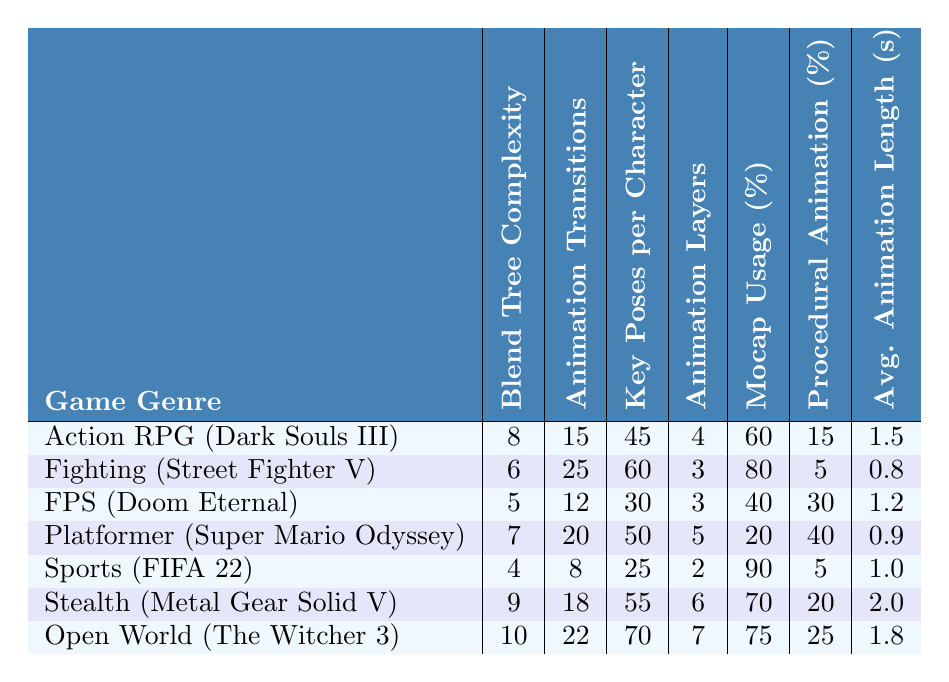What is the blend tree complexity for the Fighting genre? According to the table, the Fighting genre has a blend tree complexity of 6.
Answer: 6 Which game has the highest number of key poses per character? The Open World genre (The Witcher 3) has the highest number of key poses per character at 70.
Answer: 70 How many animation transitions does the Action RPG genre have? The Action RPG genre (Dark Souls III) has 15 animation transitions.
Answer: 15 Which genre has the lowest average animation length? The Fighting genre (Street Fighter V) has the lowest average animation length of 0.8 seconds.
Answer: 0.8 seconds What is the difference in blend tree complexity between the Open World and Sports genres? The Open World genre has a complexity of 10, while the Sports genre has a complexity of 4. The difference is 10 - 4 = 6.
Answer: 6 True or False: The FPS genre uses more motion capture percentage than the Action RPG genre. The FPS genre (Doom Eternal) uses 40% motion capture while the Action RPG genre (Dark Souls III) uses 60%. Thus, the statement is false.
Answer: False What is the average number of animation layers across all genres? The total animation layers are 4 + 3 + 3 + 5 + 2 + 6 + 7 = 30 and there are 7 genres. The average is 30 / 7 ≈ 4.29.
Answer: Approximately 4.29 Which genre uses the least amount of procedural animation in percentage? The Sports genre (FIFA 22) uses the least procedural animation at 5%.
Answer: 5% If you compare the blend tree complexity of Stealth and Platformer genres, which is greater and by how much? The Stealth genre (Metal Gear Solid V) has a complexity of 9, and the Platformer genre (Super Mario Odyssey) has a complexity of 7. The difference is 9 - 7 = 2.
Answer: 2 What genre has the highest mocap usage percentage, and what is the percentage? The Sports genre (FIFA 22) has the highest mocap usage percentage at 90%.
Answer: 90% 